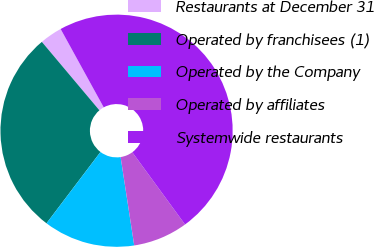Convert chart. <chart><loc_0><loc_0><loc_500><loc_500><pie_chart><fcel>Restaurants at December 31<fcel>Operated by franchisees (1)<fcel>Operated by the Company<fcel>Operated by affiliates<fcel>Systemwide restaurants<nl><fcel>3.13%<fcel>28.56%<fcel>12.74%<fcel>7.61%<fcel>47.96%<nl></chart> 